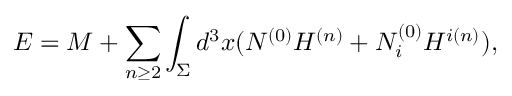Convert formula to latex. <formula><loc_0><loc_0><loc_500><loc_500>E = M + \sum _ { n \geq 2 } \int _ { \Sigma } d ^ { 3 } x ( N ^ { ( 0 ) } H ^ { ( n ) } + N _ { i } ^ { ( 0 ) } H ^ { i ( n ) } ) ,</formula> 